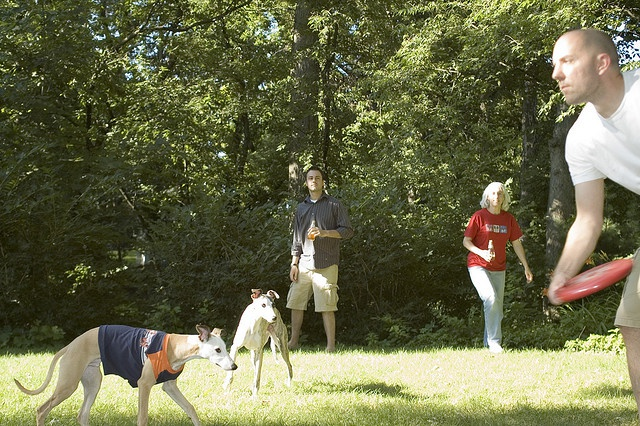Describe the objects in this image and their specific colors. I can see people in darkgreen, white, gray, darkgray, and tan tones, dog in darkgreen, tan, darkgray, ivory, and black tones, people in darkgreen, gray, black, and olive tones, people in darkgreen, white, maroon, brown, and darkgray tones, and dog in darkgreen, white, olive, beige, and tan tones in this image. 